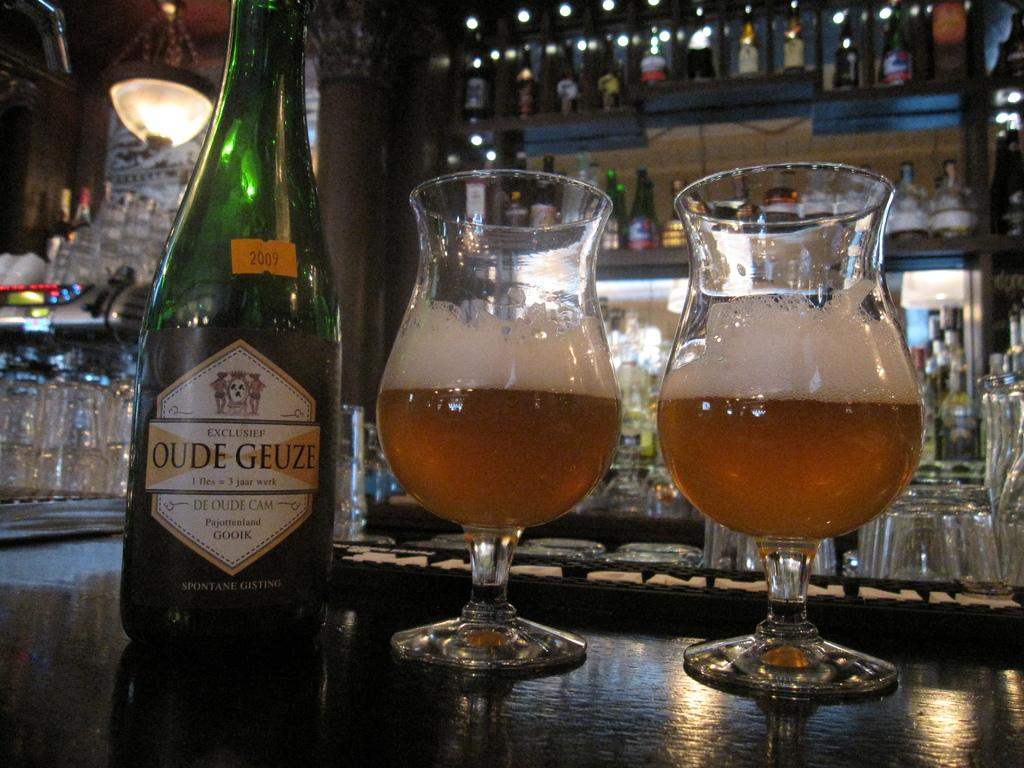<image>
Present a compact description of the photo's key features. A bottle of Oude Geuze is next to two glasses with the ale inside. 